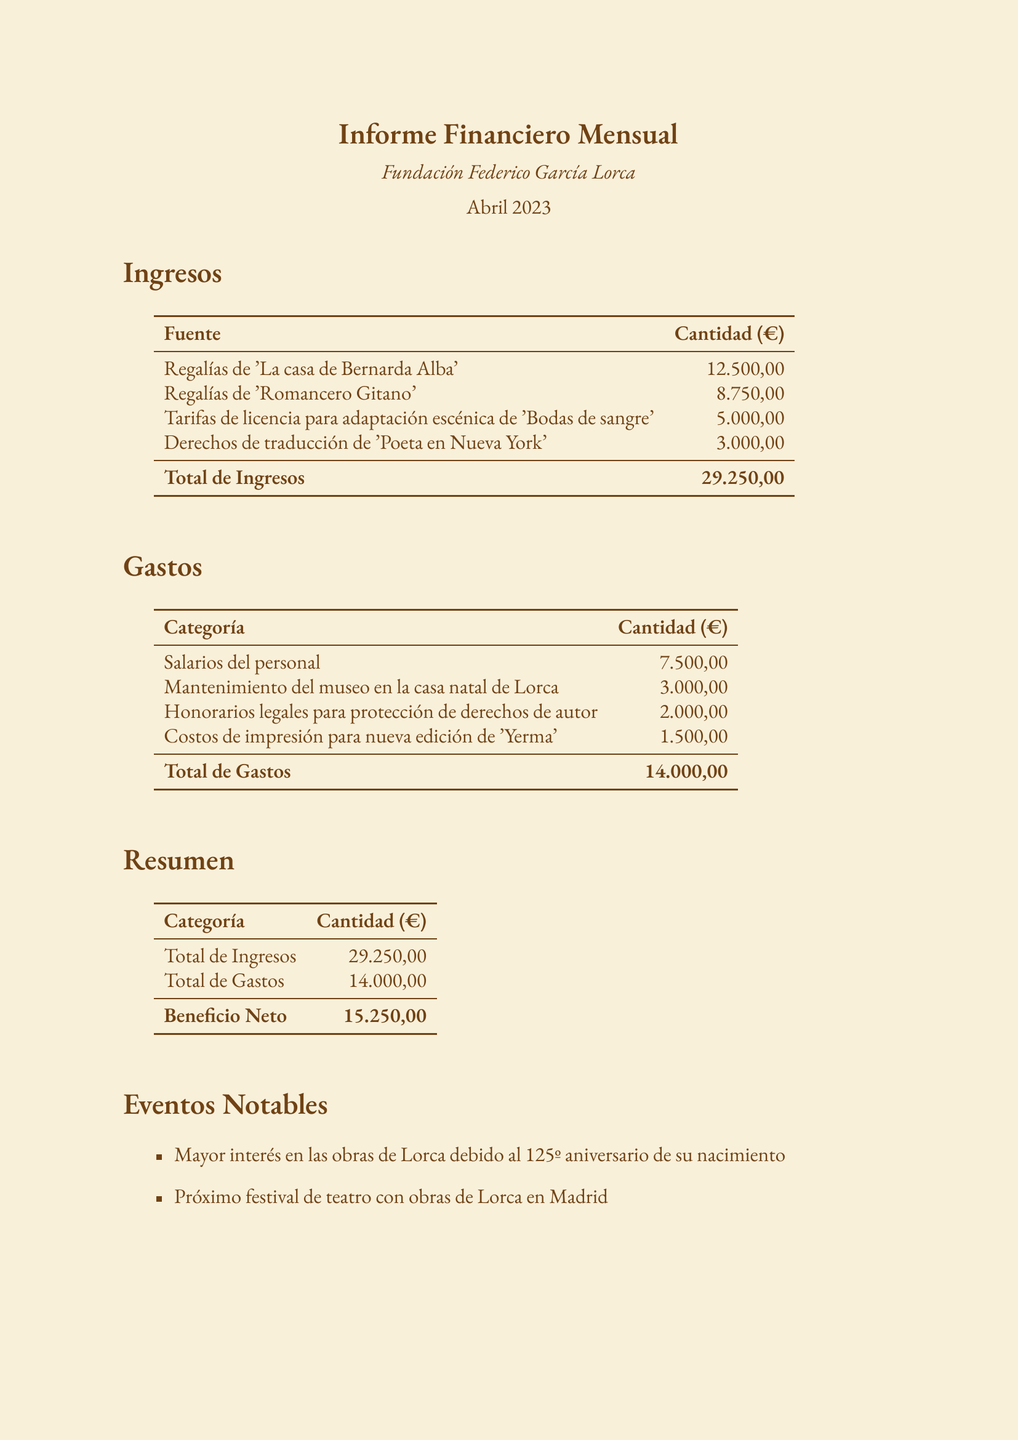What is the total income for April 2023? The total income is specifically stated in the document under the income summary section.
Answer: 29.250,00 What was spent on staff salaries? Staff salaries are explicitly listed in the expenses section of the document.
Answer: 7.500,00 What is the net profit for the period? The net profit is summarized in the report and calculated from total income minus total expenses.
Answer: 15.250,00 Which work generated the most income? The work that generated the most income is listed first in the income section of the document.
Answer: La casa de Bernarda Alba What event increased interest in Lorca's works? An event mentioned in the notable events section directly indicates why there was increased interest.
Answer: 125th birth anniversary How much is expected to be earned from royalties next quarter? Future projections indicate expected earnings based on past events highlighted in the document.
Answer: 10% increase What is the total amount spent on the maintenance of Lorca's museum? The maintenance expenses for the museum are stated in the expenses section.
Answer: 3.000,00 What was the cost of printing the new edition of 'Yerma'? The cost associated with printing the mentioned edition is explicitly listed under expenses.
Answer: 1.500,00 What type of fees were included under legal expenses? Legal fees are categorized under expenses and are mentioned in the document precisely.
Answer: Copyright protection 